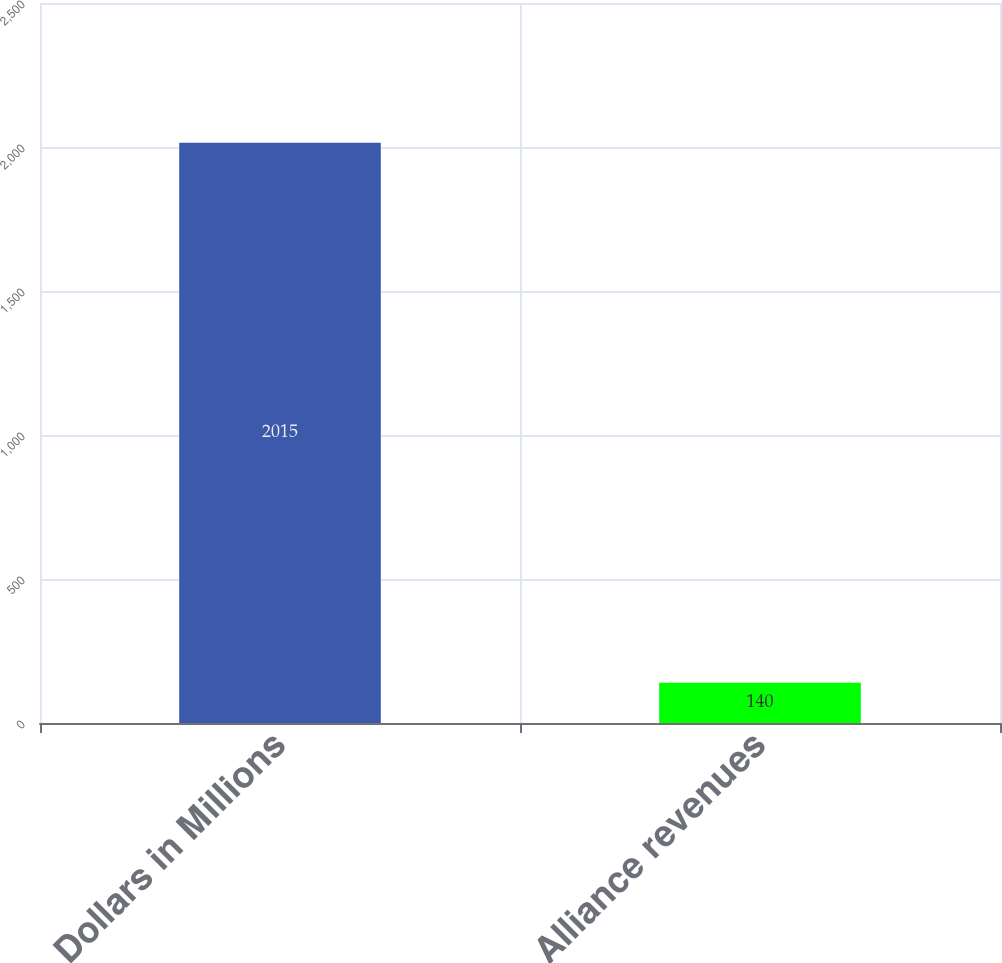Convert chart to OTSL. <chart><loc_0><loc_0><loc_500><loc_500><bar_chart><fcel>Dollars in Millions<fcel>Alliance revenues<nl><fcel>2015<fcel>140<nl></chart> 